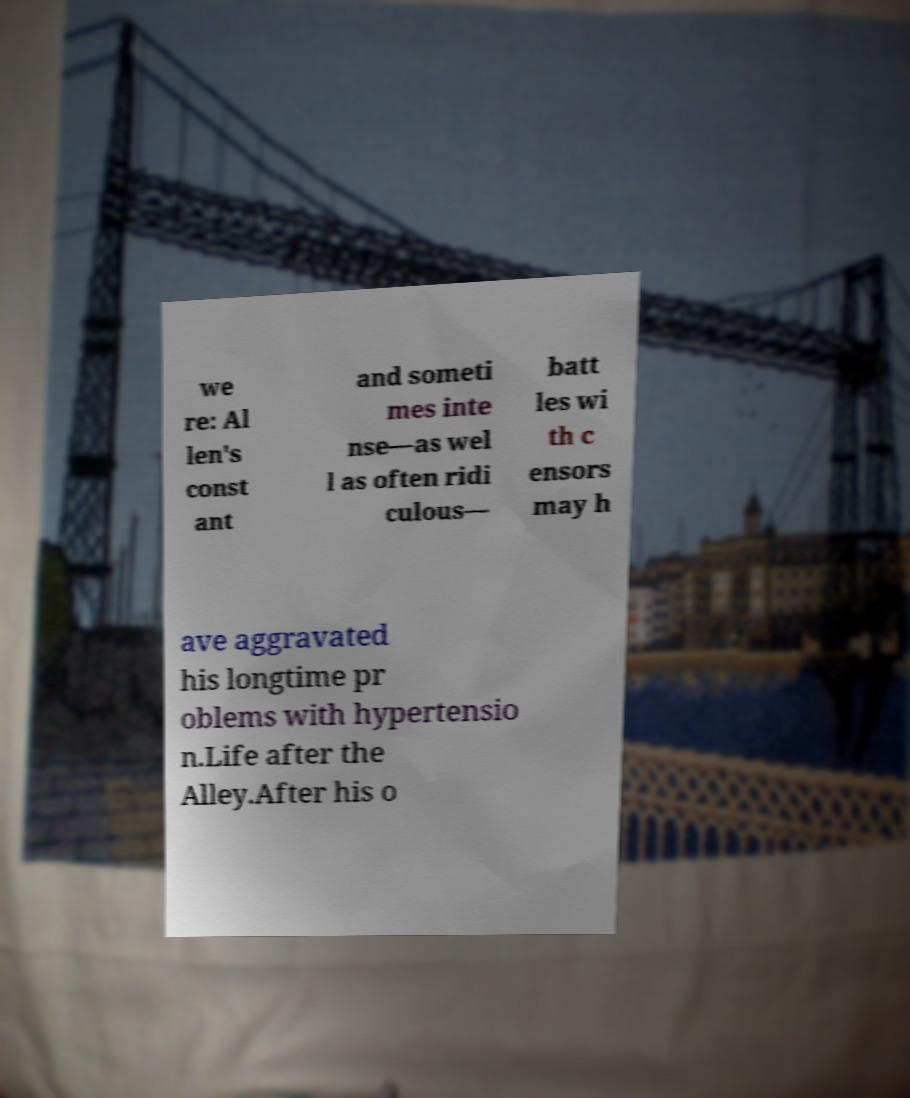For documentation purposes, I need the text within this image transcribed. Could you provide that? we re: Al len's const ant and someti mes inte nse—as wel l as often ridi culous— batt les wi th c ensors may h ave aggravated his longtime pr oblems with hypertensio n.Life after the Alley.After his o 